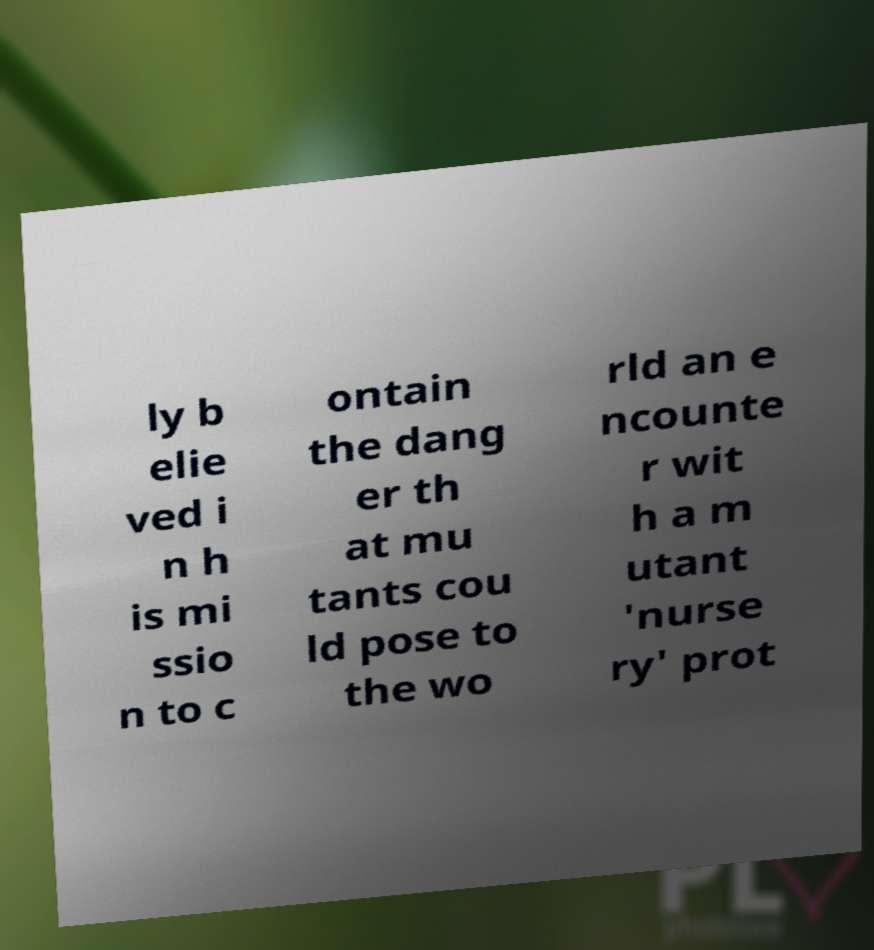What messages or text are displayed in this image? I need them in a readable, typed format. ly b elie ved i n h is mi ssio n to c ontain the dang er th at mu tants cou ld pose to the wo rld an e ncounte r wit h a m utant 'nurse ry' prot 